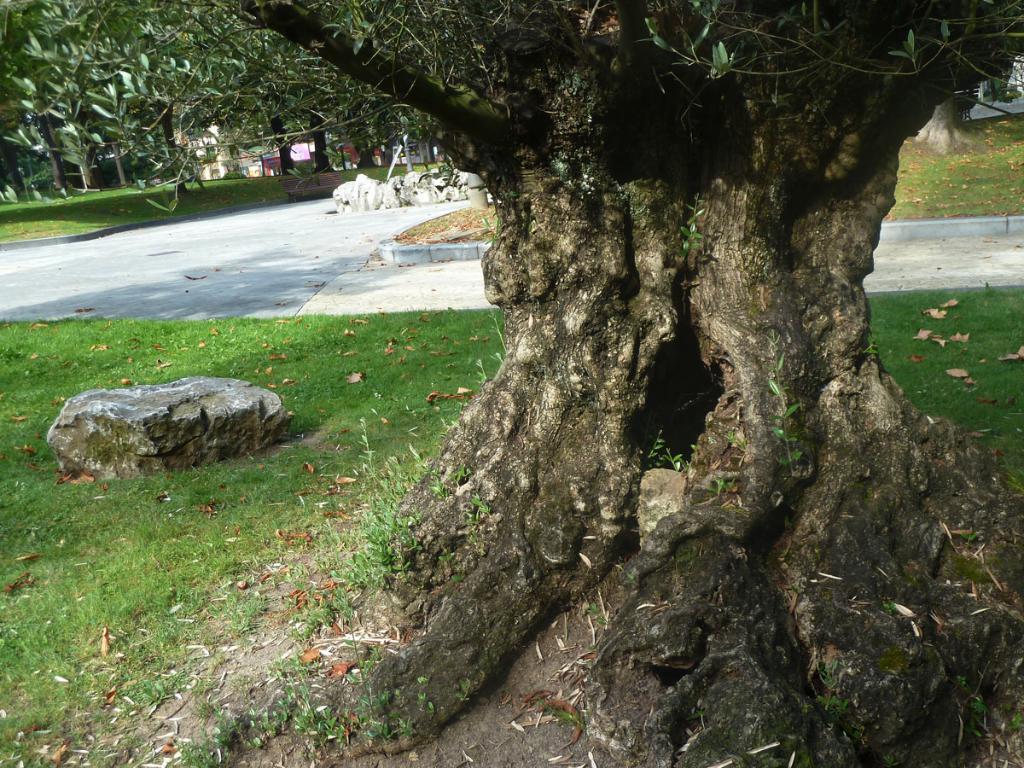Can you describe this image briefly? There is a tree trunk, rock, grass and trees at the back. 